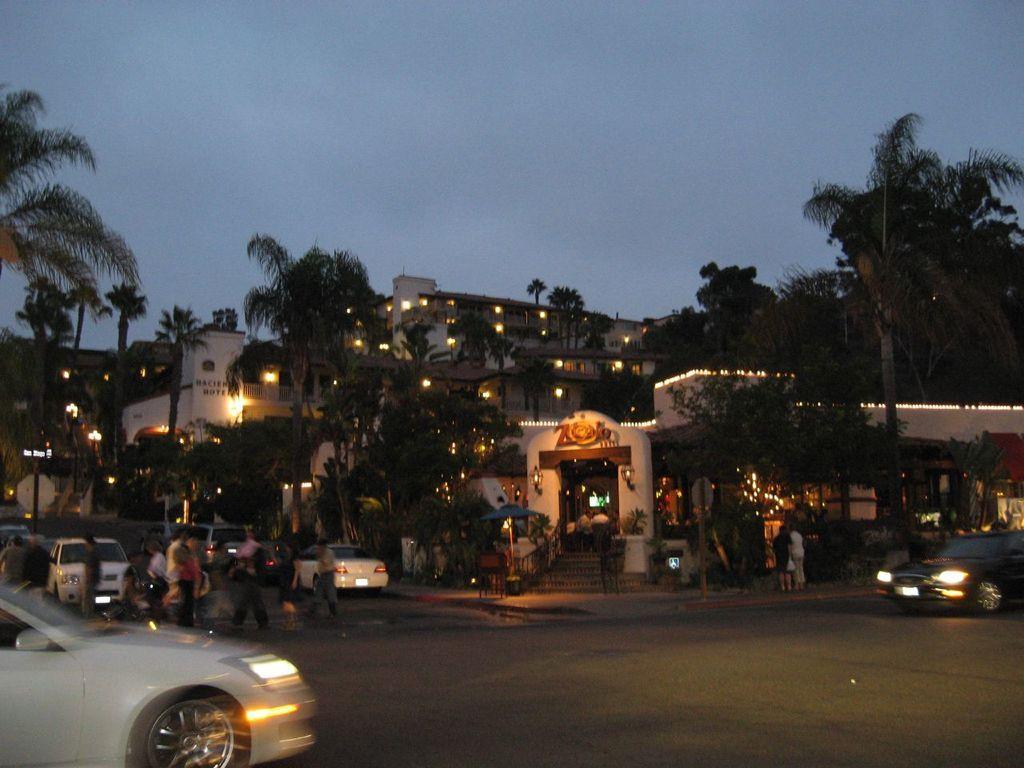Please provide a concise description of this image. In this picture I can see there are some vehicles moving on the road and in the backdrop I can see there are buildings here and there are lights attached here to the buildings and there are trees here. 